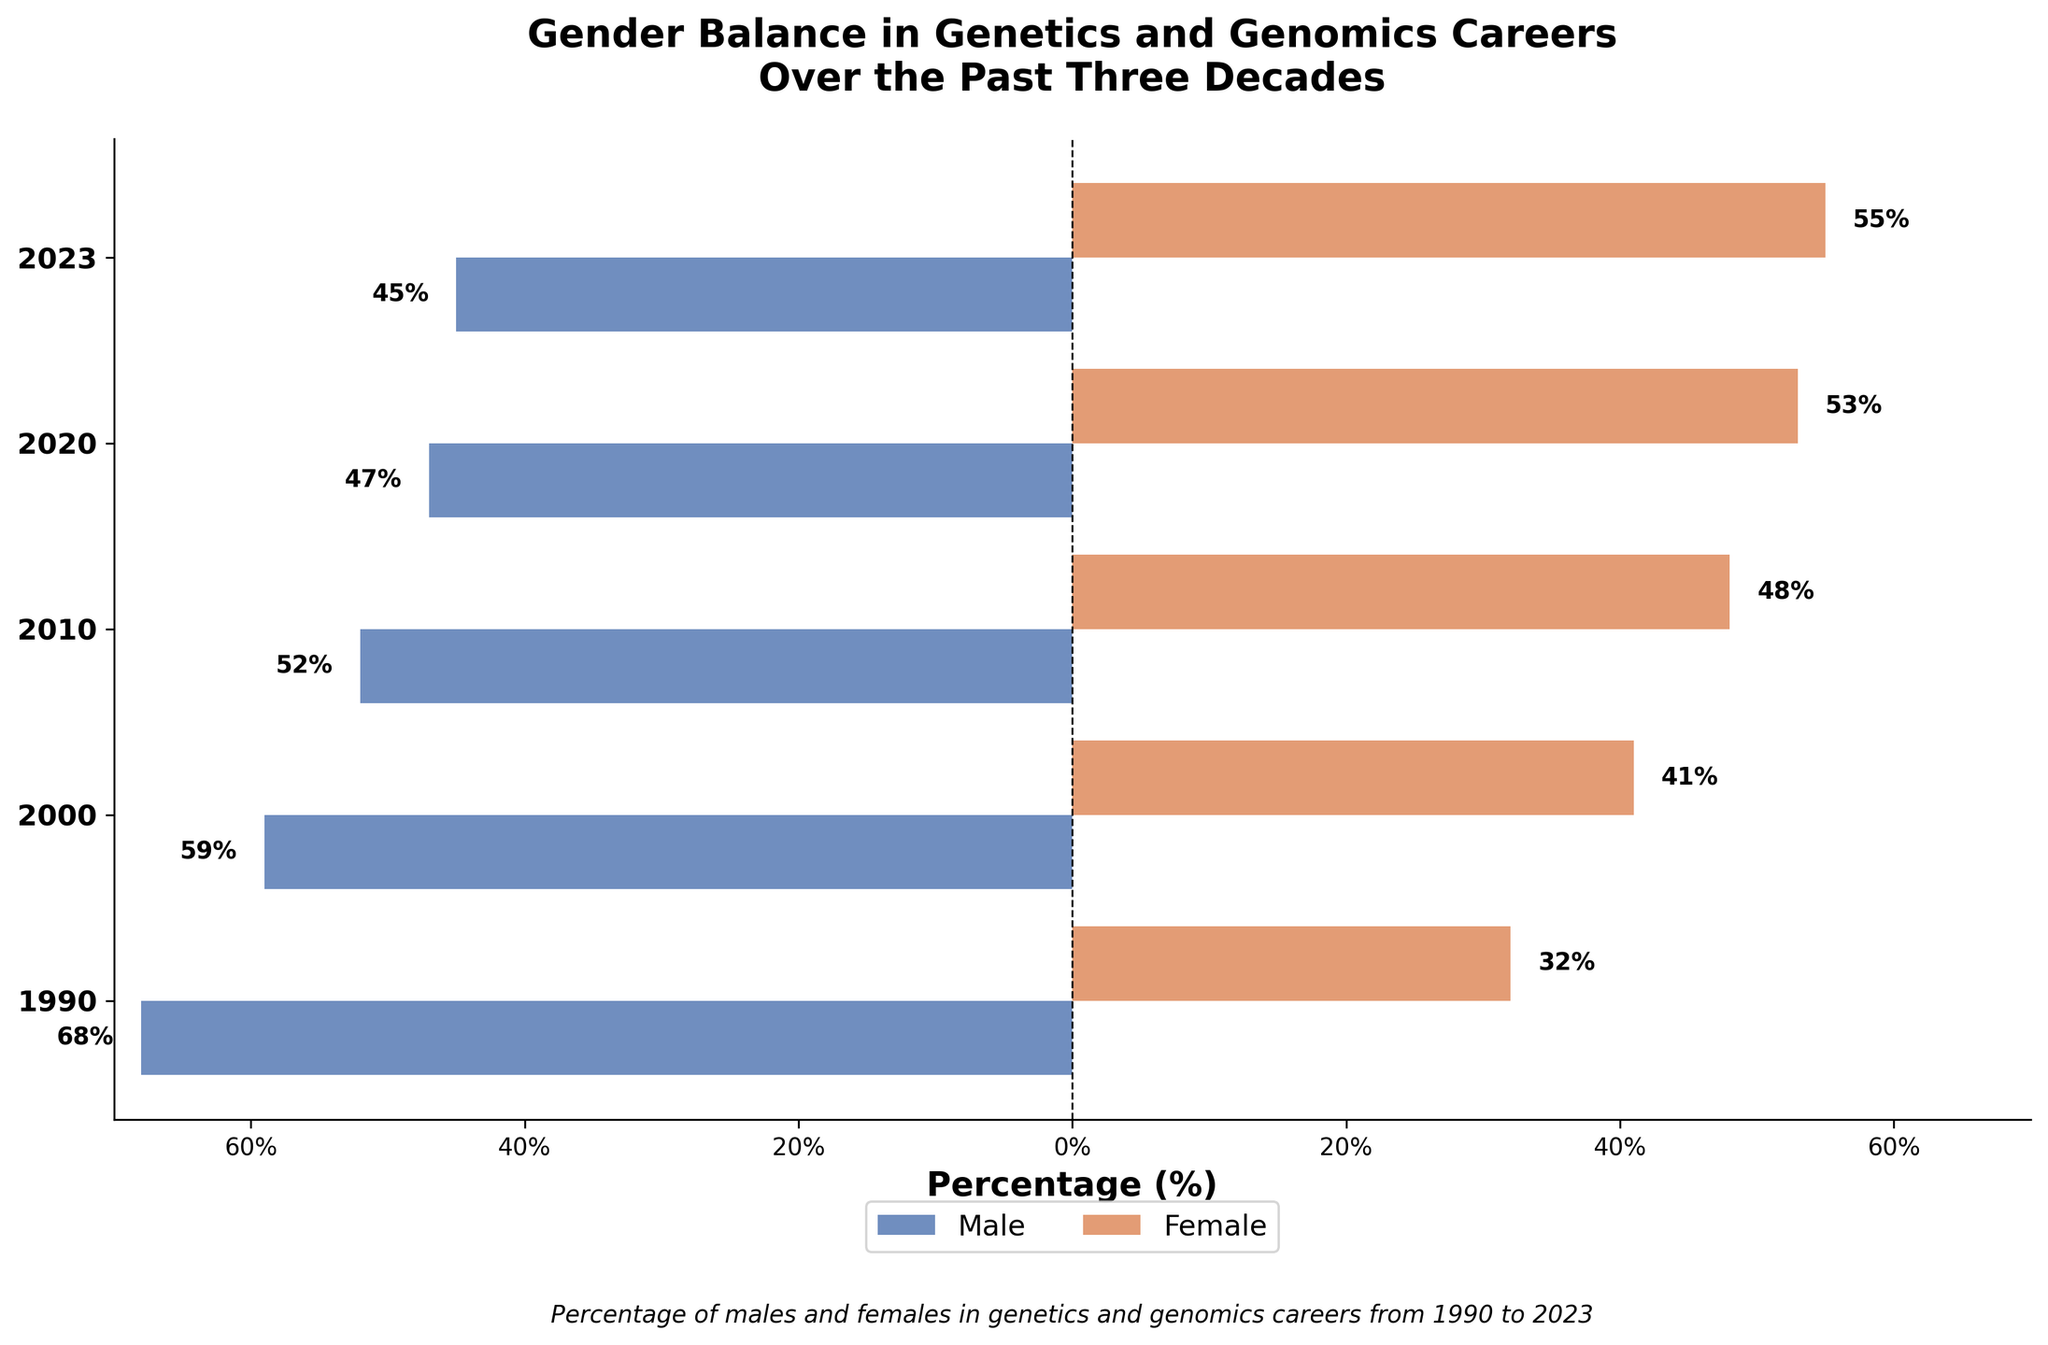What is the title of the figure? The title is typically located at the top of the figure. In this case, the title is "Gender Balance in Genetics and Genomics Careers Over the Past Three Decades".
Answer: Gender Balance in Genetics and Genomics Careers Over the Past Three Decades What is the percentage of males in genetics and genomics careers in 1990? Locate the year 1990 on the y-axis and observe the length of the male bar which extends to the left. The text label on the bar also indicates the percentage.
Answer: 68% How has the percentage of females in genetics and genomics careers changed from 1990 to 2023? Observe the percentage for females in the year 1990 (32%) and the year 2023 (55%). Compare these values to see the change.
Answer: Increased by 23% In which year did females surpass males in genetics and genomics careers? Identify the years on the y-axis and observe when the female bar lengths surpass the male bar lengths. The crossover happens between 2010 and 2020.
Answer: 2020 Which gender had the highest percentage in genetics and genomics careers in 2000 and by how much? For the year 2000, compare the lengths of the male and female bars. The male bar is longer with a percentage of 59%, while the female bar is at 41%. The difference is the absolute difference between these values.
Answer: Male by 18% What was the average percentage of males in genetics and genomics careers between 1990 and 2023? Add the male percentages for each year (68 + 59 + 52 + 47 + 45) and divide by the number of years (5) to find the average.
Answer: 54.2% How does the trend of male percentages compare to female percentages over time? Observe the trend lines formed by the bar lengths from 1990 to 2023 for both genders. While male percentages are consistently decreasing, female percentages are increasing.
Answer: Male percentages decrease, female percentages increase By what percentage did the male participation in genetics and genomics careers decrease from 1990 to 2023? Subtract the male percentage in 2023 (45%) from the male percentage in 1990 (68%) to find the decrease.
Answer: 23% What can you infer about gender balance trends in genetics and genomics careers based on this figure? Based on the decreasing percentages of males and increasing percentages of females over the years, it can be inferred that there has gradually been a shift towards gender balance, with females surpassing males in recent years.
Answer: Shift towards gender balance What is the difference in female participation percentages between the years 2000 and 2020? Subtract the female percentage in 2000 (41%) from the female percentage in 2020 (53%) to find the difference.
Answer: 12% 